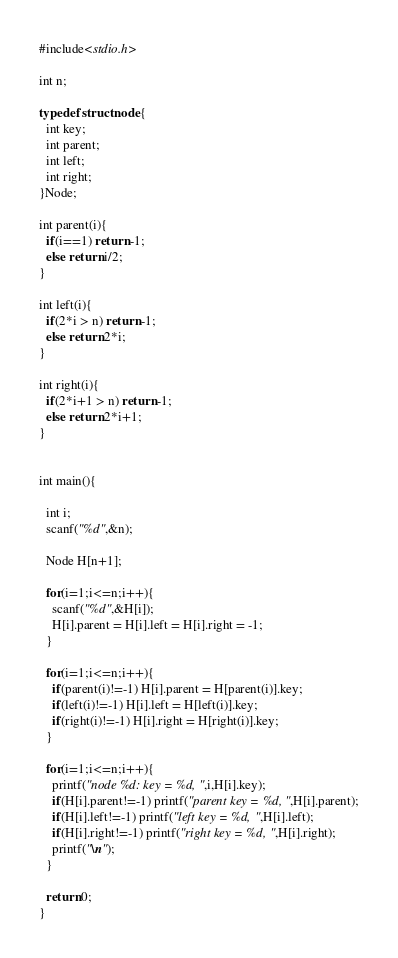<code> <loc_0><loc_0><loc_500><loc_500><_C_>#include<stdio.h>

int n;

typedef struct node{
  int key;
  int parent;
  int left;
  int right;
}Node;

int parent(i){
  if(i==1) return -1;
  else return i/2;
}

int left(i){
  if(2*i > n) return -1;
  else return 2*i;
}

int right(i){
  if(2*i+1 > n) return -1;
  else return 2*i+1;
}
	       

int main(){

  int i;
  scanf("%d",&n);

  Node H[n+1];

  for(i=1;i<=n;i++){
    scanf("%d",&H[i]);
    H[i].parent = H[i].left = H[i].right = -1;
  }

  for(i=1;i<=n;i++){
    if(parent(i)!=-1) H[i].parent = H[parent(i)].key;
    if(left(i)!=-1) H[i].left = H[left(i)].key;
    if(right(i)!=-1) H[i].right = H[right(i)].key;
  }

  for(i=1;i<=n;i++){
    printf("node %d: key = %d, ",i,H[i].key);
    if(H[i].parent!=-1) printf("parent key = %d, ",H[i].parent);
    if(H[i].left!=-1) printf("left key = %d, ",H[i].left);
    if(H[i].right!=-1) printf("right key = %d, ",H[i].right);
    printf("\n");
  }
  
  return 0;
}

</code> 